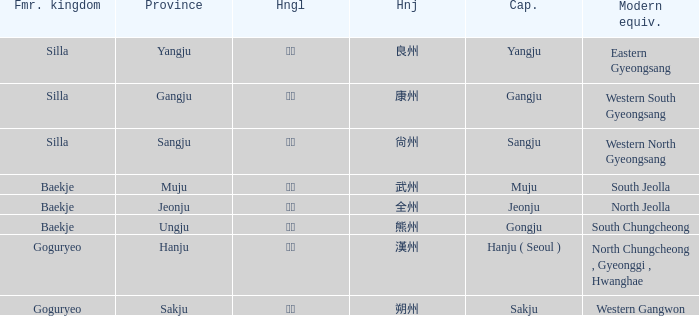The hanja 朔州 is for what province? Sakju. 